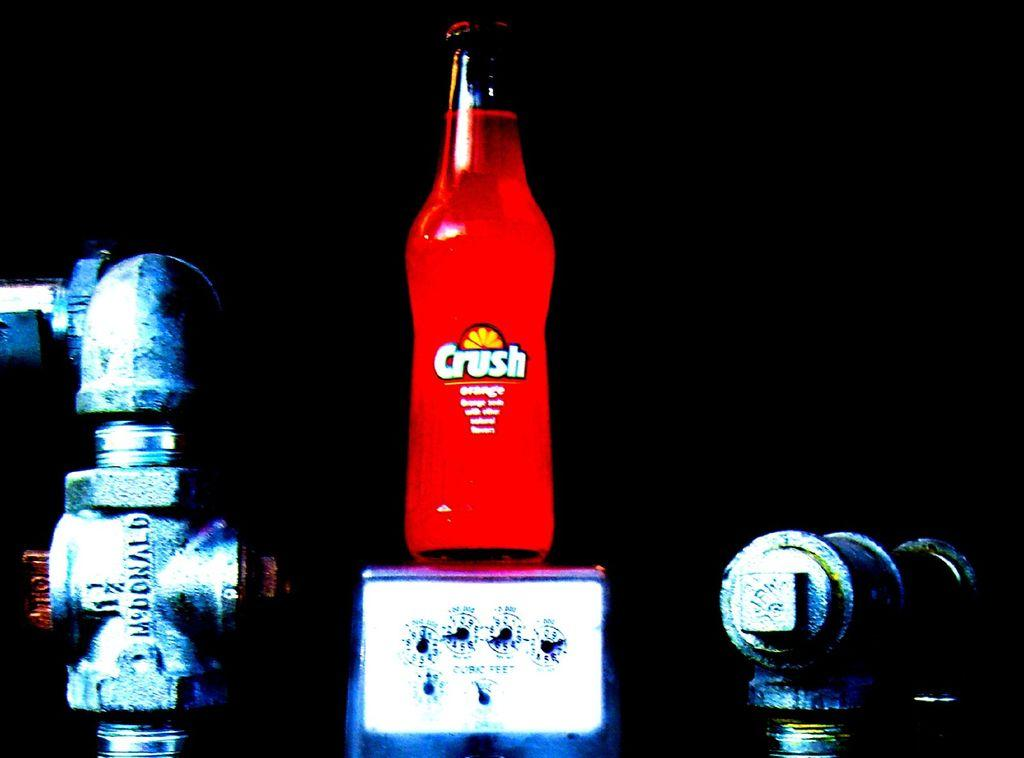<image>
Write a terse but informative summary of the picture. A orange Crush clear soda bottle that is sitting on plumbing with a black background. 